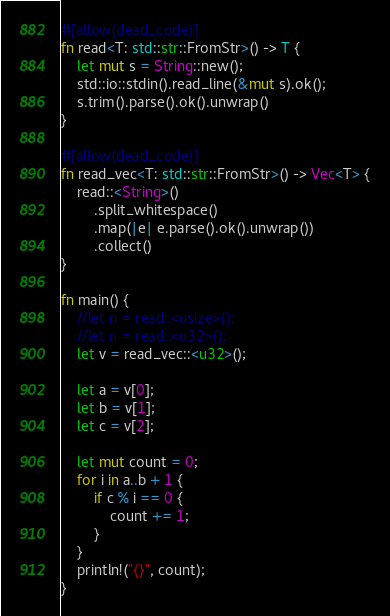Convert code to text. <code><loc_0><loc_0><loc_500><loc_500><_Rust_>#[allow(dead_code)]
fn read<T: std::str::FromStr>() -> T {
    let mut s = String::new();
    std::io::stdin().read_line(&mut s).ok();
    s.trim().parse().ok().unwrap()
}

#[allow(dead_code)]
fn read_vec<T: std::str::FromStr>() -> Vec<T> {
    read::<String>()
        .split_whitespace()
        .map(|e| e.parse().ok().unwrap())
        .collect()
}

fn main() {
    //let n = read::<usize>();
    //let n = read::<u32>();
    let v = read_vec::<u32>();

    let a = v[0];
    let b = v[1];
    let c = v[2];

    let mut count = 0;
    for i in a..b + 1 {
        if c % i == 0 {
            count += 1;
        }
    }
    println!("{}", count);
}

</code> 